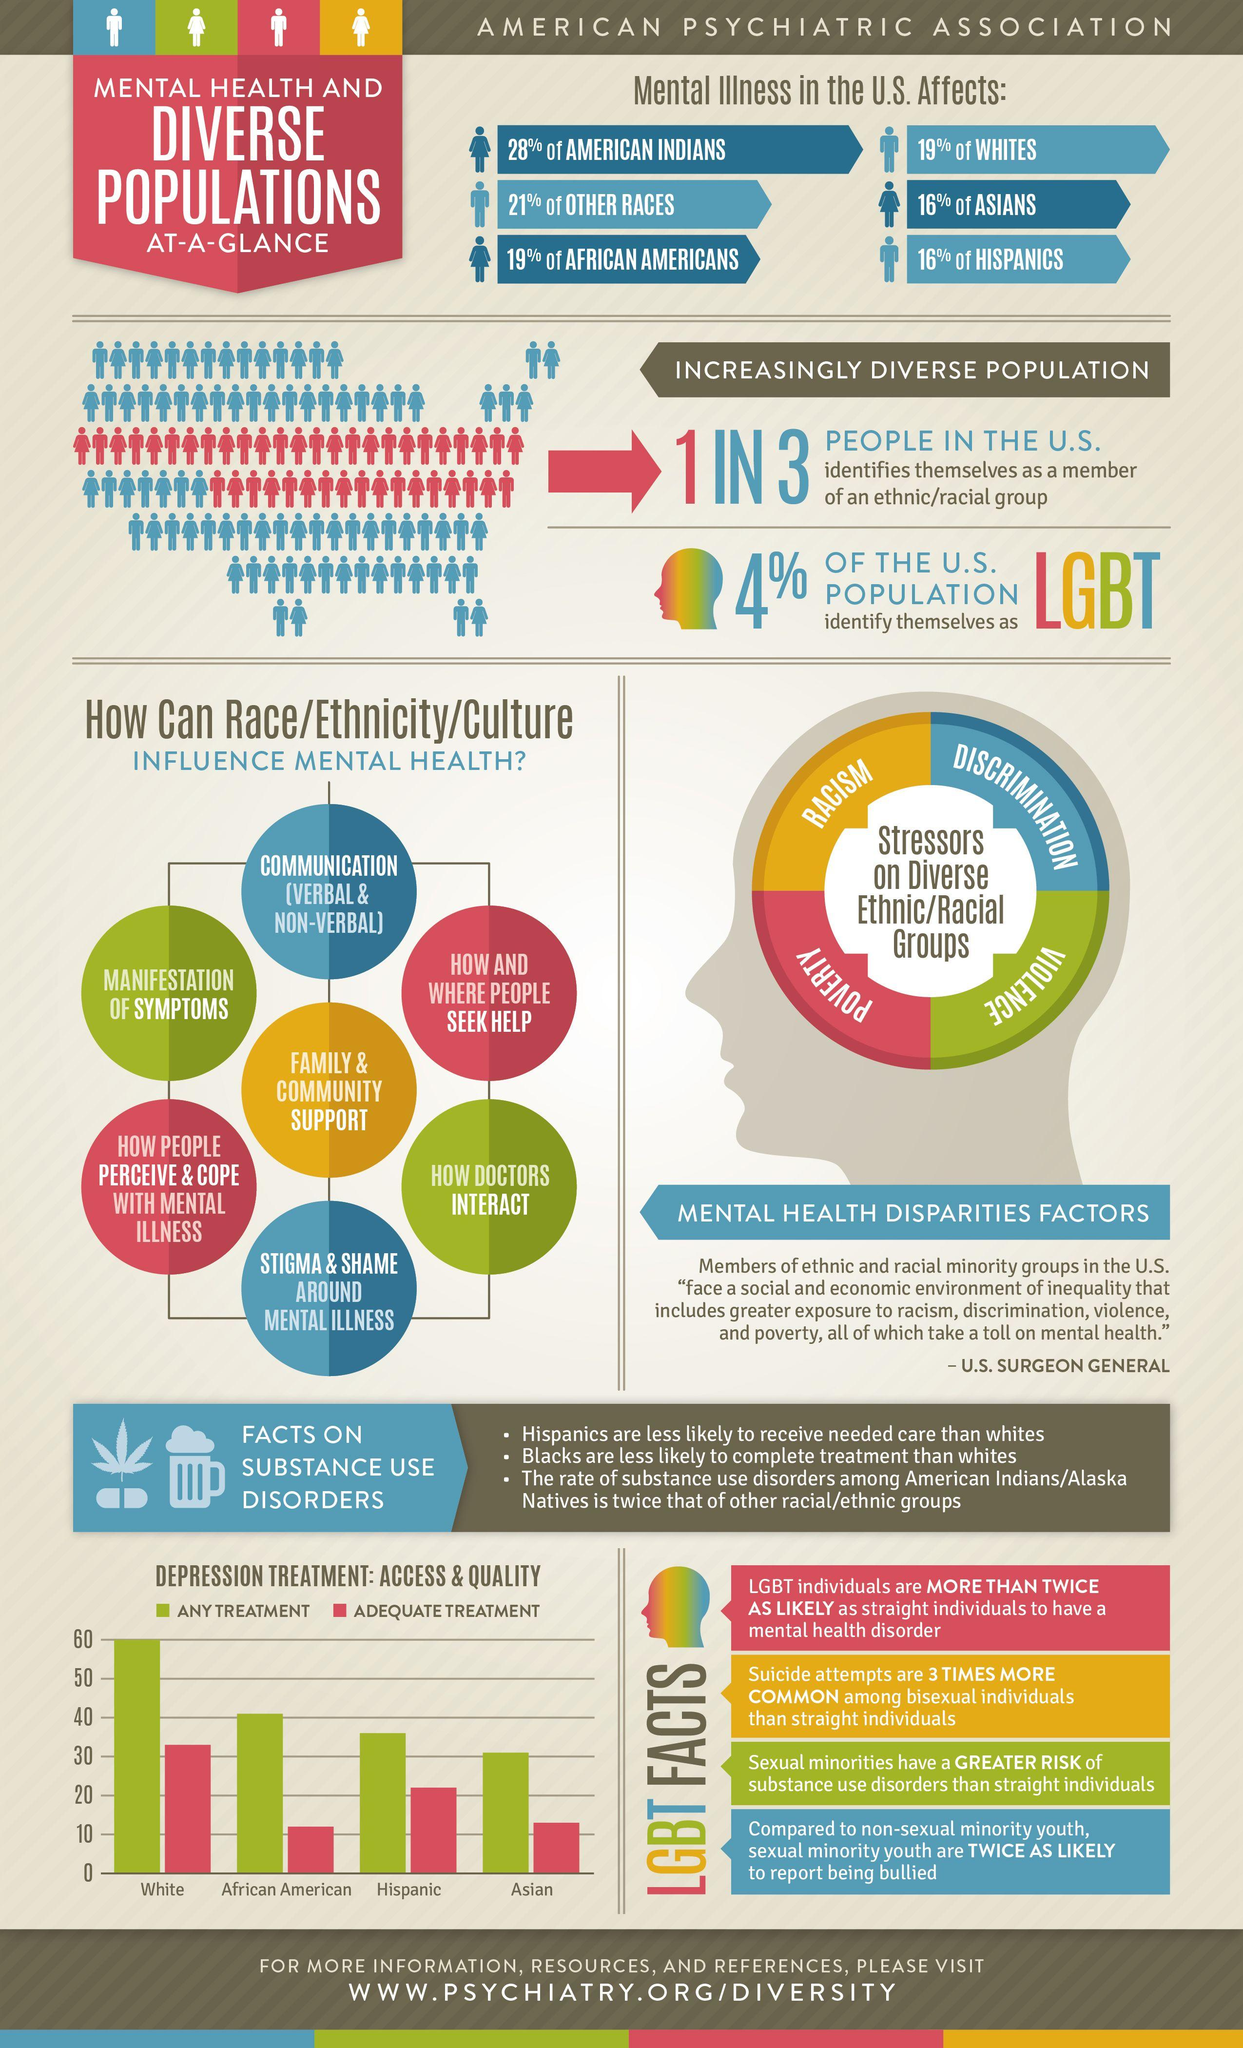Outline some significant characteristics in this image. In the United States, American Indians are disproportionately affected by mental illness. The influence of race, ethnicity, and culture on mental health is discussed in detail in seven points. 